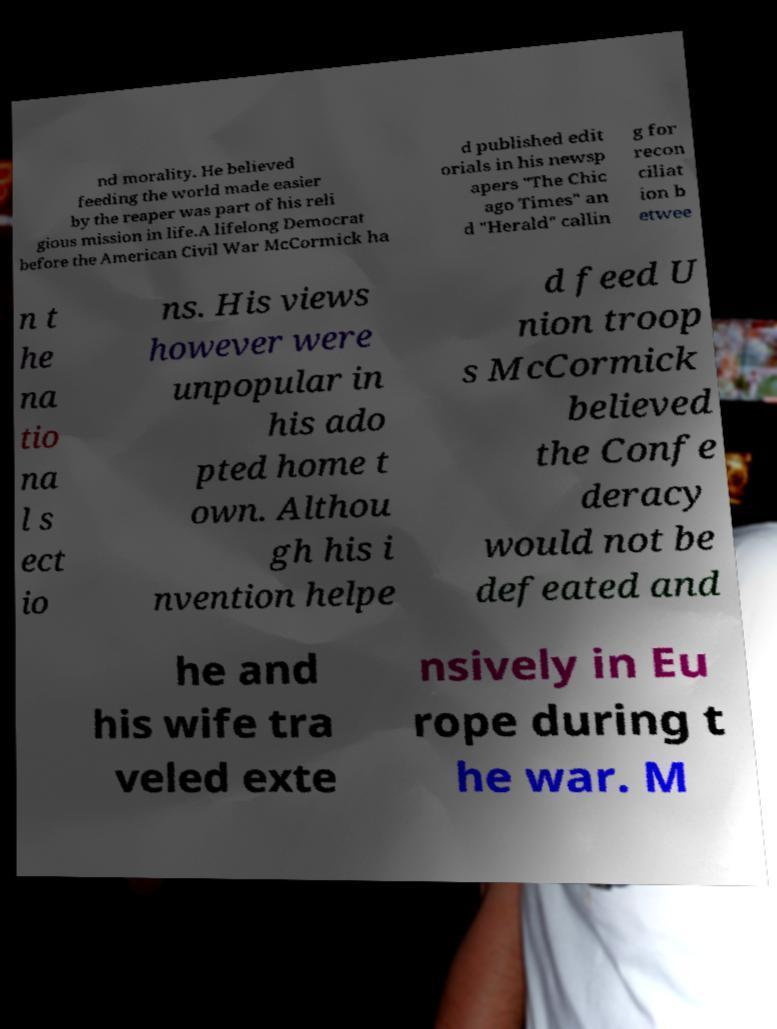For documentation purposes, I need the text within this image transcribed. Could you provide that? nd morality. He believed feeding the world made easier by the reaper was part of his reli gious mission in life.A lifelong Democrat before the American Civil War McCormick ha d published edit orials in his newsp apers "The Chic ago Times" an d "Herald" callin g for recon ciliat ion b etwee n t he na tio na l s ect io ns. His views however were unpopular in his ado pted home t own. Althou gh his i nvention helpe d feed U nion troop s McCormick believed the Confe deracy would not be defeated and he and his wife tra veled exte nsively in Eu rope during t he war. M 